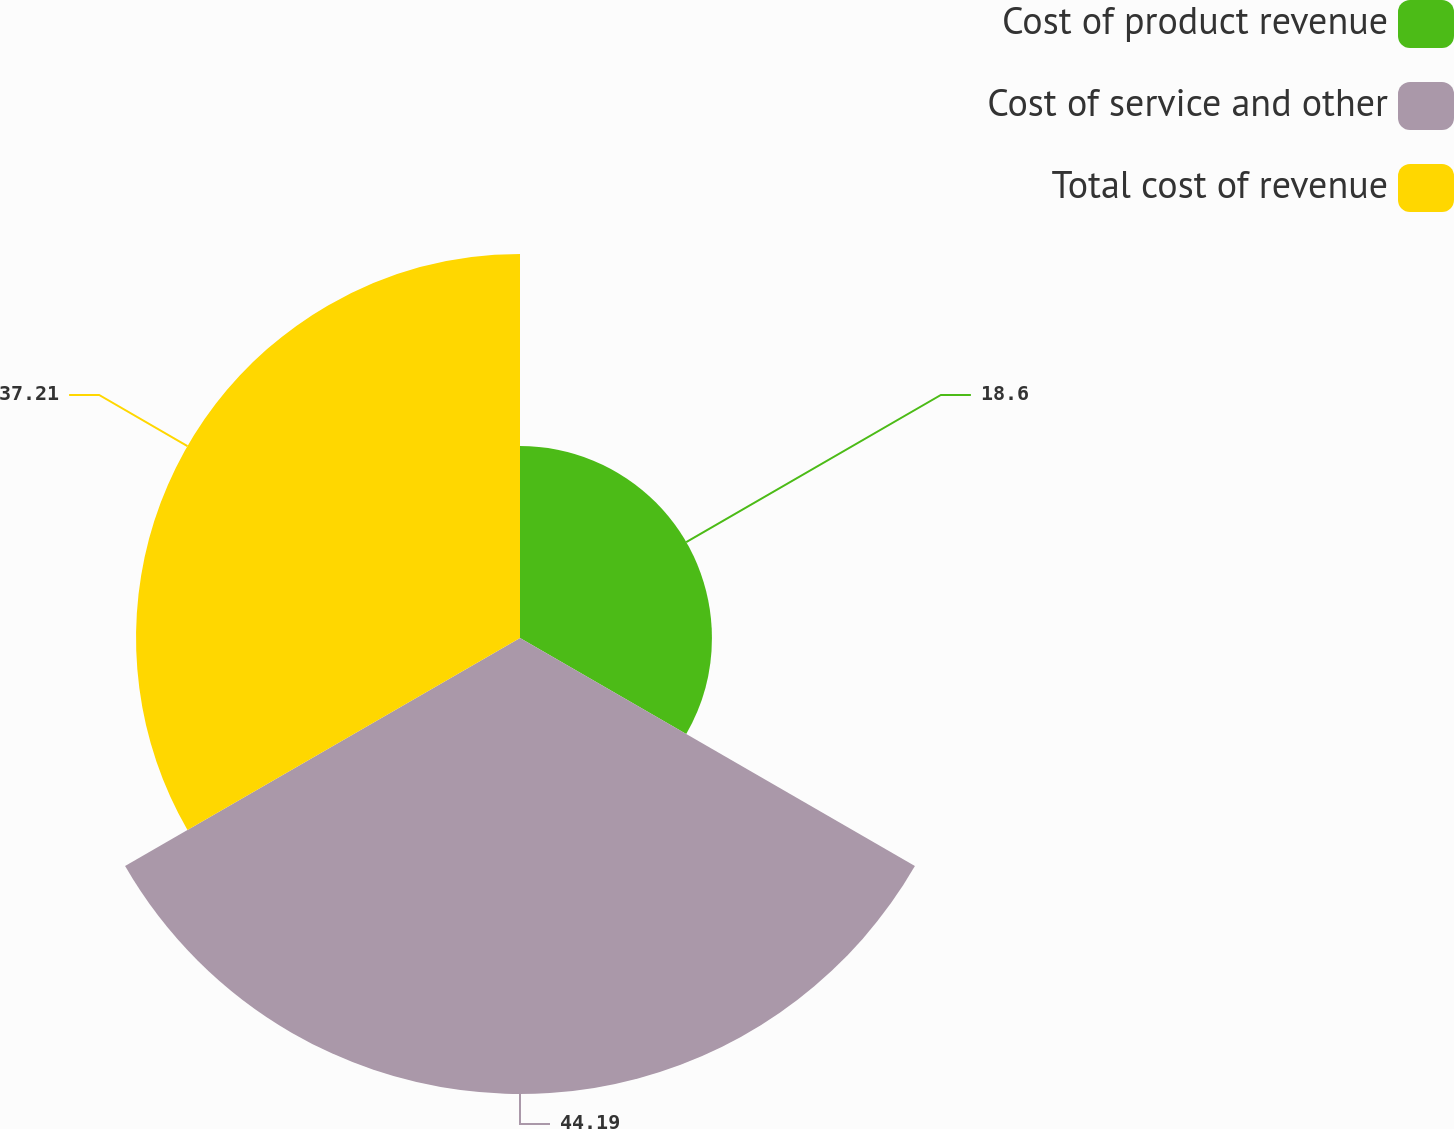Convert chart. <chart><loc_0><loc_0><loc_500><loc_500><pie_chart><fcel>Cost of product revenue<fcel>Cost of service and other<fcel>Total cost of revenue<nl><fcel>18.6%<fcel>44.19%<fcel>37.21%<nl></chart> 